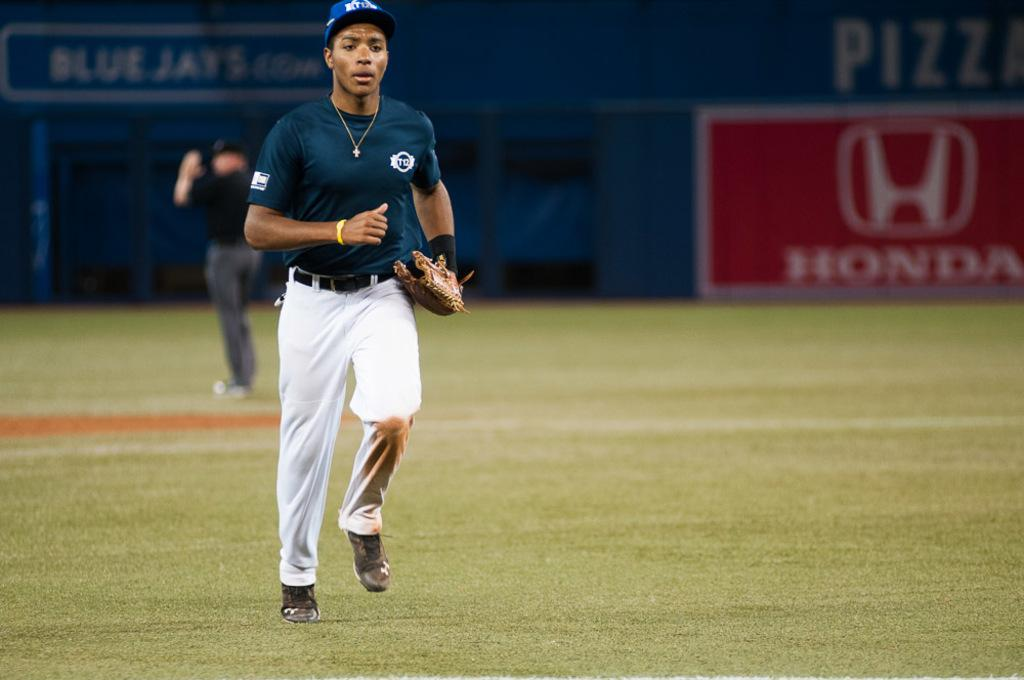<image>
Share a concise interpretation of the image provided. A baseball player jogging across a field that has a Honda billboard in the background. 